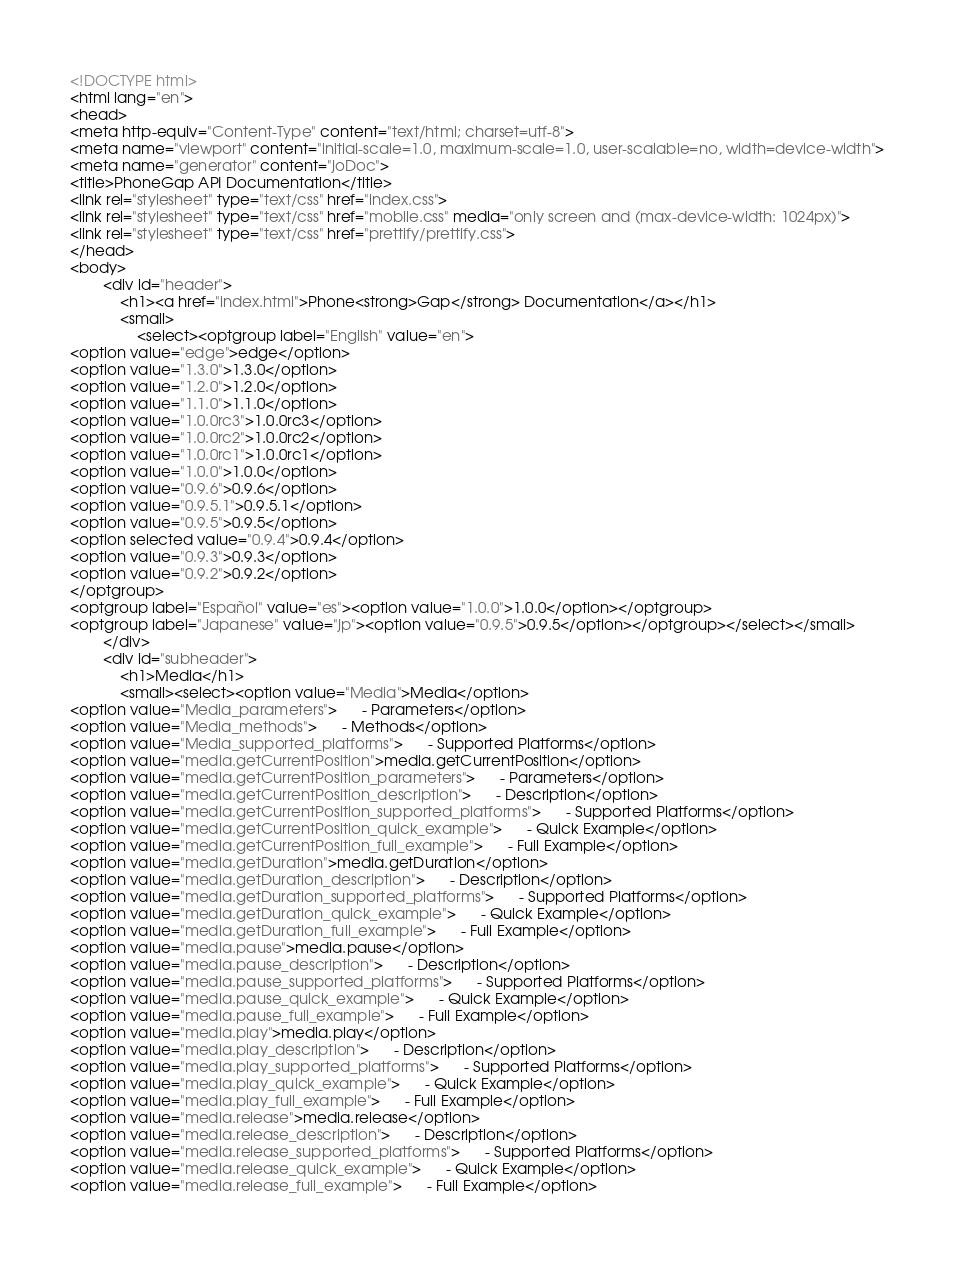Convert code to text. <code><loc_0><loc_0><loc_500><loc_500><_HTML_><!DOCTYPE html>
<html lang="en">
<head>
<meta http-equiv="Content-Type" content="text/html; charset=utf-8">
<meta name="viewport" content="initial-scale=1.0, maximum-scale=1.0, user-scalable=no, width=device-width">
<meta name="generator" content="joDoc">
<title>PhoneGap API Documentation</title>
<link rel="stylesheet" type="text/css" href="index.css">
<link rel="stylesheet" type="text/css" href="mobile.css" media="only screen and (max-device-width: 1024px)">
<link rel="stylesheet" type="text/css" href="prettify/prettify.css">
</head>
<body>
        <div id="header">
            <h1><a href="index.html">Phone<strong>Gap</strong> Documentation</a></h1>
            <small>
                <select><optgroup label="English" value="en">
<option value="edge">edge</option>
<option value="1.3.0">1.3.0</option>
<option value="1.2.0">1.2.0</option>
<option value="1.1.0">1.1.0</option>
<option value="1.0.0rc3">1.0.0rc3</option>
<option value="1.0.0rc2">1.0.0rc2</option>
<option value="1.0.0rc1">1.0.0rc1</option>
<option value="1.0.0">1.0.0</option>
<option value="0.9.6">0.9.6</option>
<option value="0.9.5.1">0.9.5.1</option>
<option value="0.9.5">0.9.5</option>
<option selected value="0.9.4">0.9.4</option>
<option value="0.9.3">0.9.3</option>
<option value="0.9.2">0.9.2</option>
</optgroup>
<optgroup label="Español" value="es"><option value="1.0.0">1.0.0</option></optgroup>
<optgroup label="Japanese" value="jp"><option value="0.9.5">0.9.5</option></optgroup></select></small>
        </div>
        <div id="subheader">
            <h1>Media</h1>
            <small><select><option value="Media">Media</option>
<option value="Media_parameters">      - Parameters</option>
<option value="Media_methods">      - Methods</option>
<option value="Media_supported_platforms">      - Supported Platforms</option>
<option value="media.getCurrentPosition">media.getCurrentPosition</option>
<option value="media.getCurrentPosition_parameters">      - Parameters</option>
<option value="media.getCurrentPosition_description">      - Description</option>
<option value="media.getCurrentPosition_supported_platforms">      - Supported Platforms</option>
<option value="media.getCurrentPosition_quick_example">      - Quick Example</option>
<option value="media.getCurrentPosition_full_example">      - Full Example</option>
<option value="media.getDuration">media.getDuration</option>
<option value="media.getDuration_description">      - Description</option>
<option value="media.getDuration_supported_platforms">      - Supported Platforms</option>
<option value="media.getDuration_quick_example">      - Quick Example</option>
<option value="media.getDuration_full_example">      - Full Example</option>
<option value="media.pause">media.pause</option>
<option value="media.pause_description">      - Description</option>
<option value="media.pause_supported_platforms">      - Supported Platforms</option>
<option value="media.pause_quick_example">      - Quick Example</option>
<option value="media.pause_full_example">      - Full Example</option>
<option value="media.play">media.play</option>
<option value="media.play_description">      - Description</option>
<option value="media.play_supported_platforms">      - Supported Platforms</option>
<option value="media.play_quick_example">      - Quick Example</option>
<option value="media.play_full_example">      - Full Example</option>
<option value="media.release">media.release</option>
<option value="media.release_description">      - Description</option>
<option value="media.release_supported_platforms">      - Supported Platforms</option>
<option value="media.release_quick_example">      - Quick Example</option>
<option value="media.release_full_example">      - Full Example</option></code> 